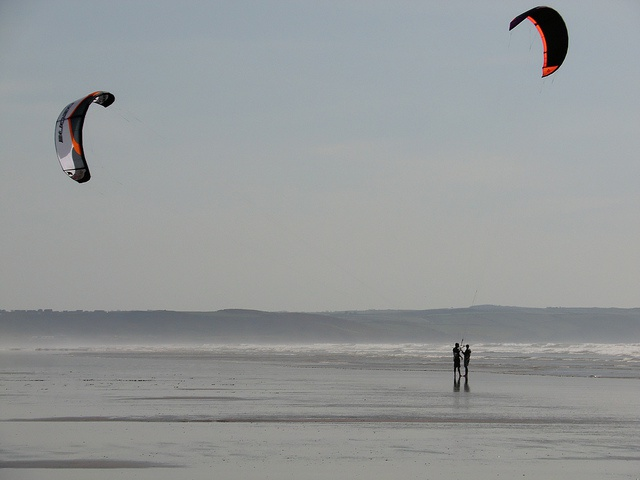Describe the objects in this image and their specific colors. I can see kite in gray, black, and darkgray tones, kite in gray, black, red, and darkgray tones, people in gray, black, and darkgray tones, and people in gray and black tones in this image. 